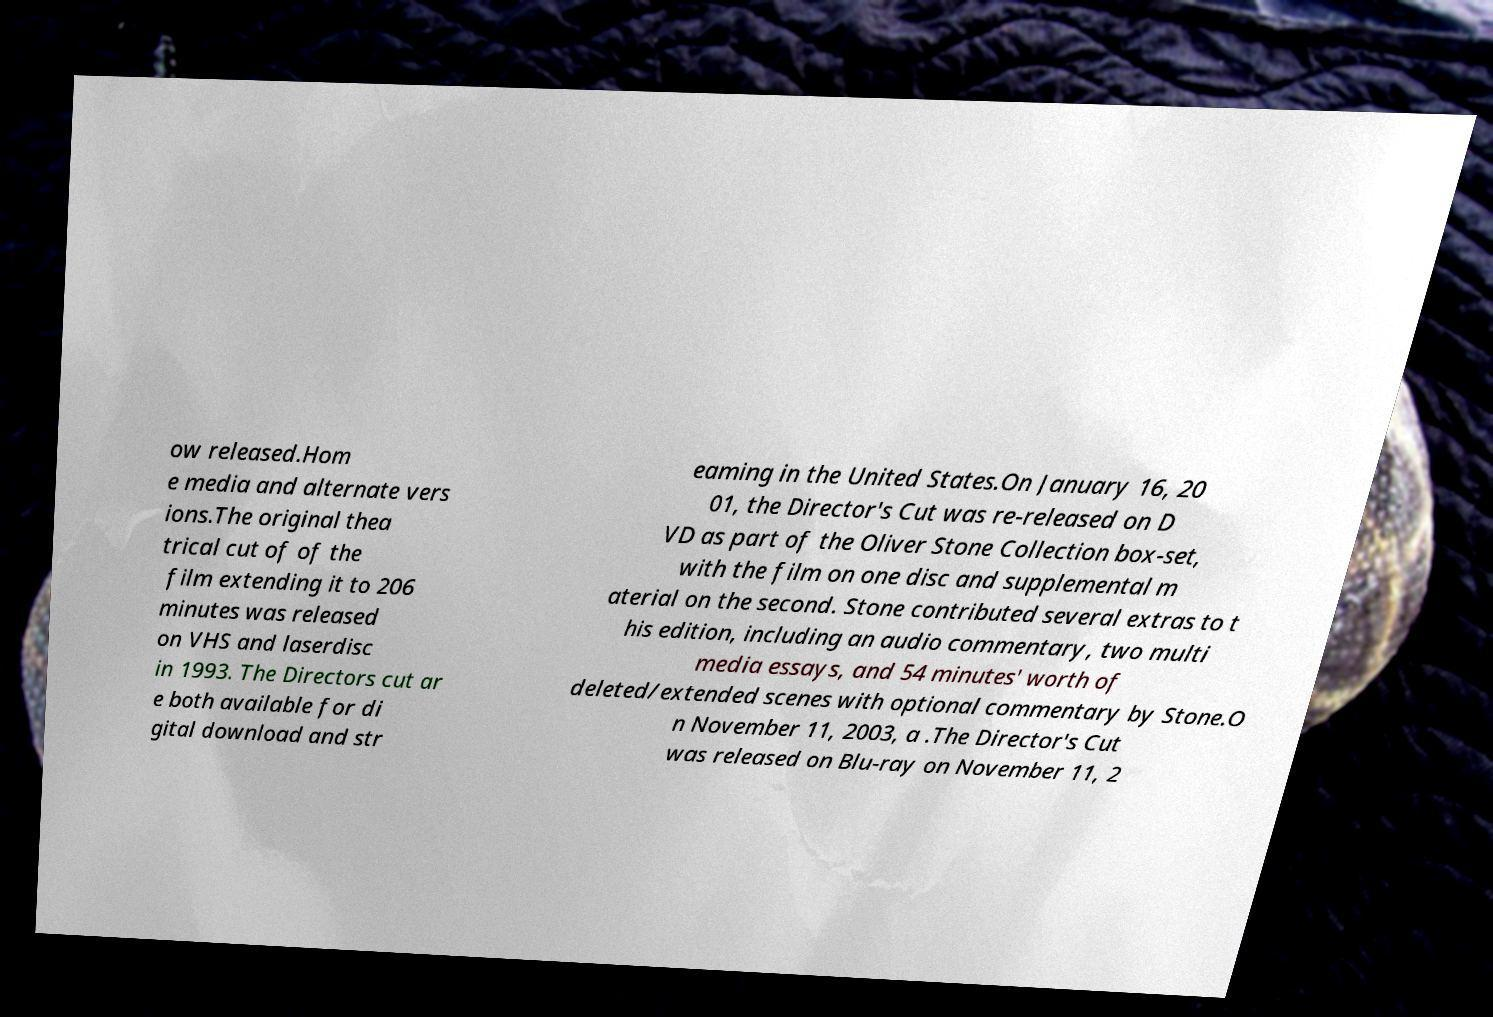There's text embedded in this image that I need extracted. Can you transcribe it verbatim? ow released.Hom e media and alternate vers ions.The original thea trical cut of of the film extending it to 206 minutes was released on VHS and laserdisc in 1993. The Directors cut ar e both available for di gital download and str eaming in the United States.On January 16, 20 01, the Director's Cut was re-released on D VD as part of the Oliver Stone Collection box-set, with the film on one disc and supplemental m aterial on the second. Stone contributed several extras to t his edition, including an audio commentary, two multi media essays, and 54 minutes' worth of deleted/extended scenes with optional commentary by Stone.O n November 11, 2003, a .The Director's Cut was released on Blu-ray on November 11, 2 